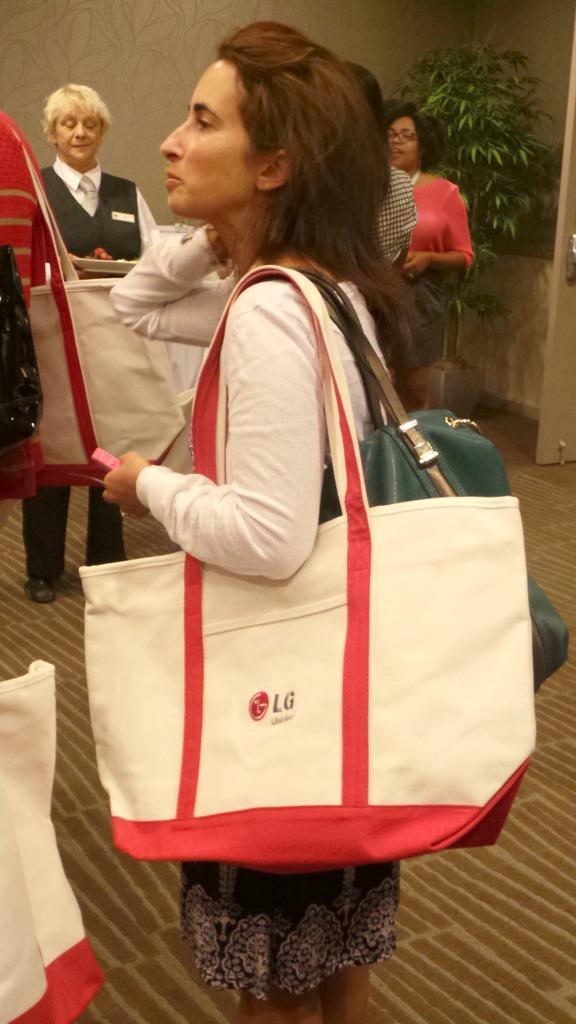Please provide a concise description of this image. In this Image I see a woman, who is standing and she is carrying bags, In the background I see few persons and I see the wall and a plant over here. 